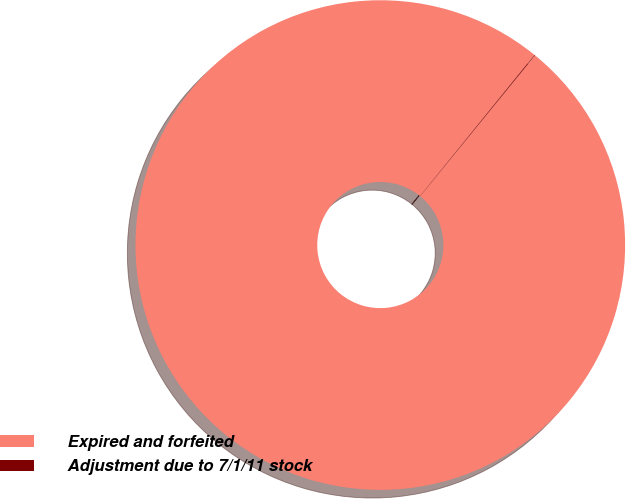Convert chart. <chart><loc_0><loc_0><loc_500><loc_500><pie_chart><fcel>Expired and forfeited<fcel>Adjustment due to 7/1/11 stock<nl><fcel>99.96%<fcel>0.04%<nl></chart> 